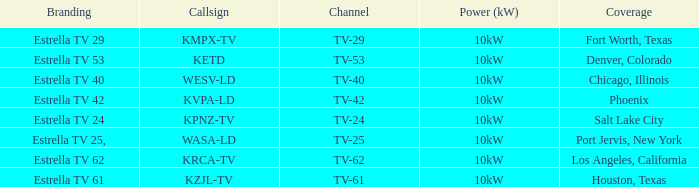Which area did estrella tv 62 provide coverage for? Los Angeles, California. 